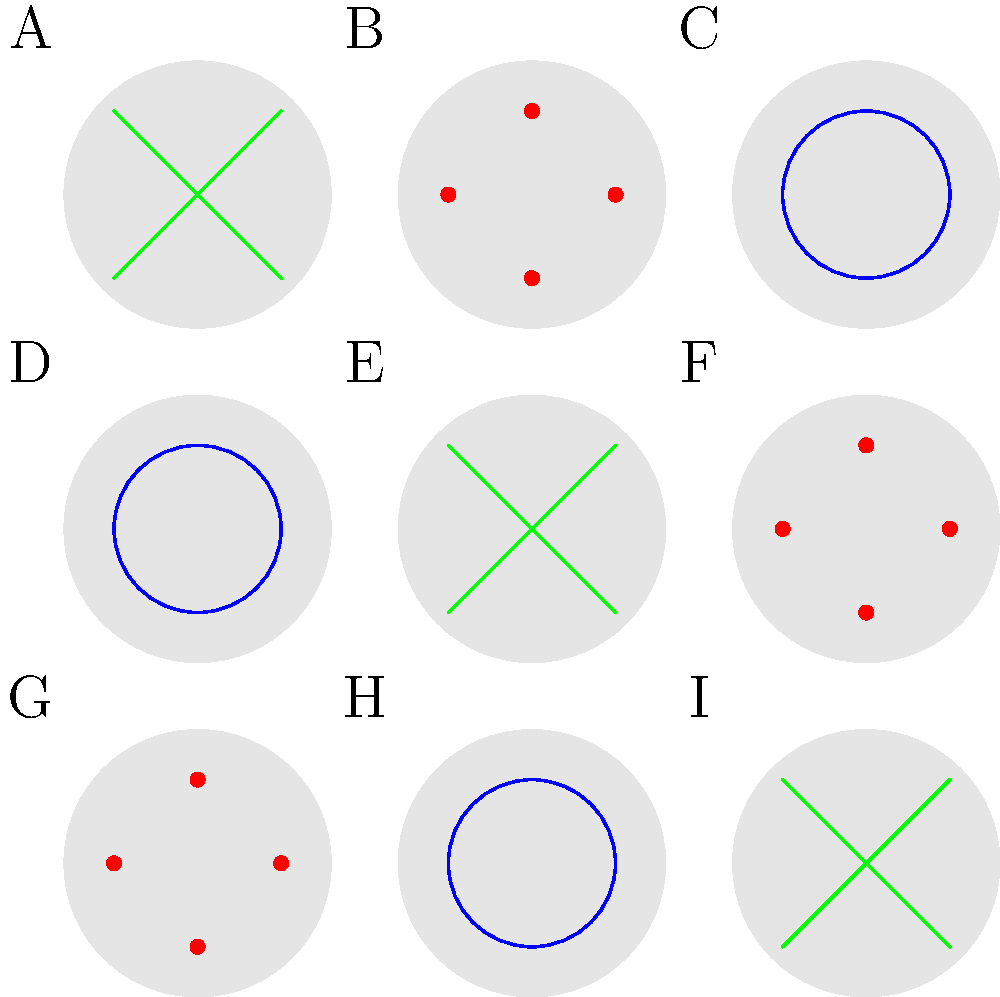As you browse through a collection of handmade stuffed toys for your children's room, you notice a pattern in their designs. The toys are arranged in a 3x3 grid, each with a unique decoration. If the pattern continues, what decoration would you expect to find on a toy placed in position J, if it were added below toy G? To solve this problem, let's analyze the pattern step-by-step:

1. Observe that there are three types of decorations:
   - Red dots (4 dots arranged in a square)
   - Blue circle
   - Green cross (two intersecting lines)

2. Look at the pattern row by row:
   Row 1 (A, B, C): Red dots, Blue circle, Green cross
   Row 2 (D, E, F): Blue circle, Green cross, Red dots
   Row 3 (G, H, I): Green cross, Red dots, Blue circle

3. Notice that the pattern shifts one position to the right in each row.

4. If we were to add a fourth row, it would follow this pattern:
   Row 4 (J, K, L): The pattern would shift once more to the right

5. Since toy G has a green cross, and the pattern shifts right, toy J (below G) would have the next decoration in the sequence.

6. The sequence of decorations is: Red dots → Blue circle → Green cross → Red dots (repeating)

7. After the green cross on toy G, the next decoration would be red dots.

Therefore, if a toy were placed in position J below toy G, it would have the red dots decoration.
Answer: Red dots 